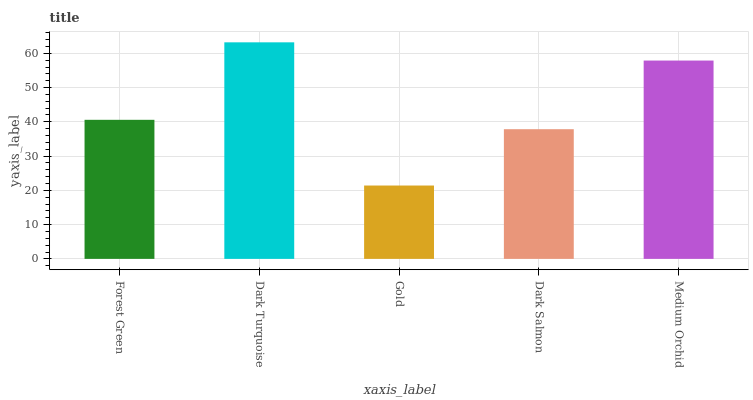Is Gold the minimum?
Answer yes or no. Yes. Is Dark Turquoise the maximum?
Answer yes or no. Yes. Is Dark Turquoise the minimum?
Answer yes or no. No. Is Gold the maximum?
Answer yes or no. No. Is Dark Turquoise greater than Gold?
Answer yes or no. Yes. Is Gold less than Dark Turquoise?
Answer yes or no. Yes. Is Gold greater than Dark Turquoise?
Answer yes or no. No. Is Dark Turquoise less than Gold?
Answer yes or no. No. Is Forest Green the high median?
Answer yes or no. Yes. Is Forest Green the low median?
Answer yes or no. Yes. Is Dark Salmon the high median?
Answer yes or no. No. Is Dark Salmon the low median?
Answer yes or no. No. 